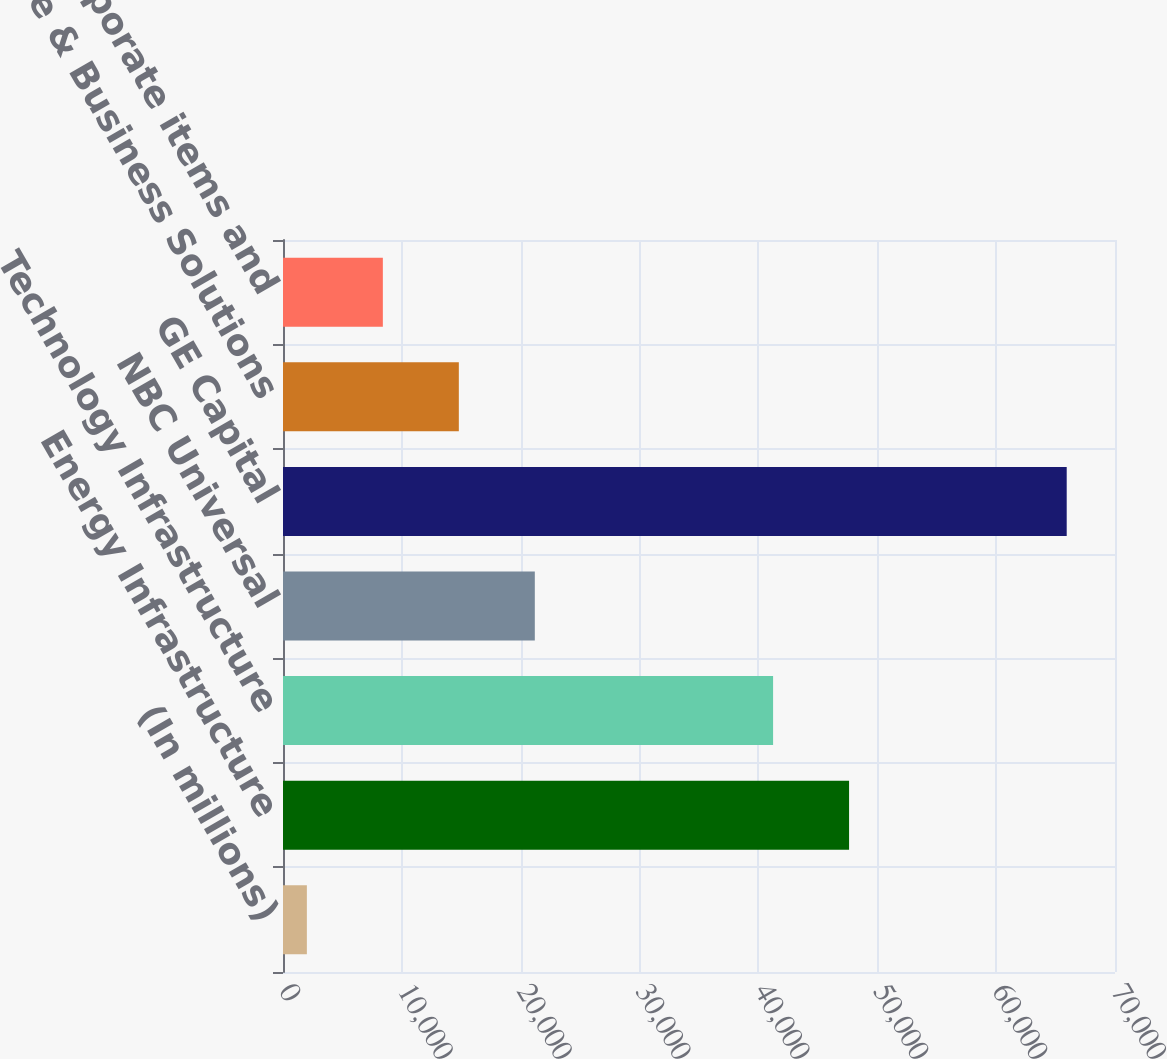Convert chart to OTSL. <chart><loc_0><loc_0><loc_500><loc_500><bar_chart><fcel>(In millions)<fcel>Energy Infrastructure<fcel>Technology Infrastructure<fcel>NBC Universal<fcel>GE Capital<fcel>Home & Business Solutions<fcel>Corporate items and<nl><fcel>2008<fcel>47625.9<fcel>41233<fcel>21186.7<fcel>65937<fcel>14793.8<fcel>8400.9<nl></chart> 